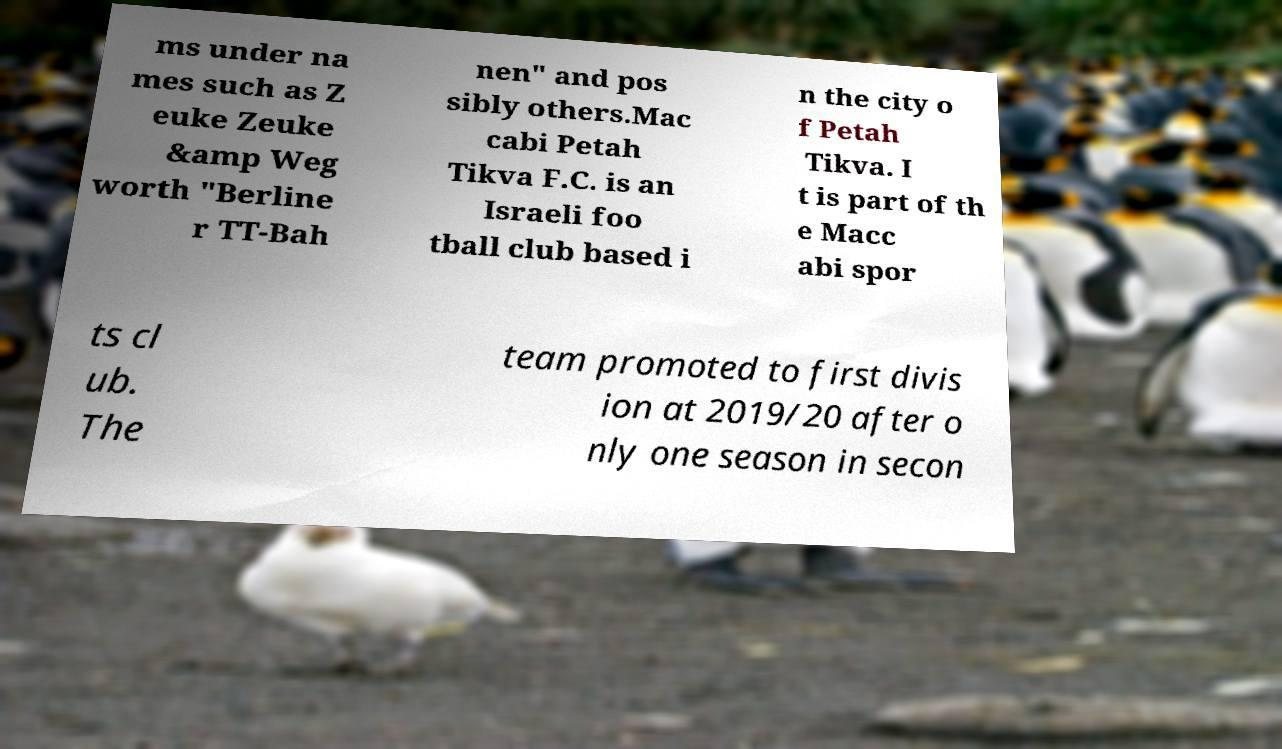For documentation purposes, I need the text within this image transcribed. Could you provide that? ms under na mes such as Z euke Zeuke &amp Weg worth "Berline r TT-Bah nen" and pos sibly others.Mac cabi Petah Tikva F.C. is an Israeli foo tball club based i n the city o f Petah Tikva. I t is part of th e Macc abi spor ts cl ub. The team promoted to first divis ion at 2019/20 after o nly one season in secon 